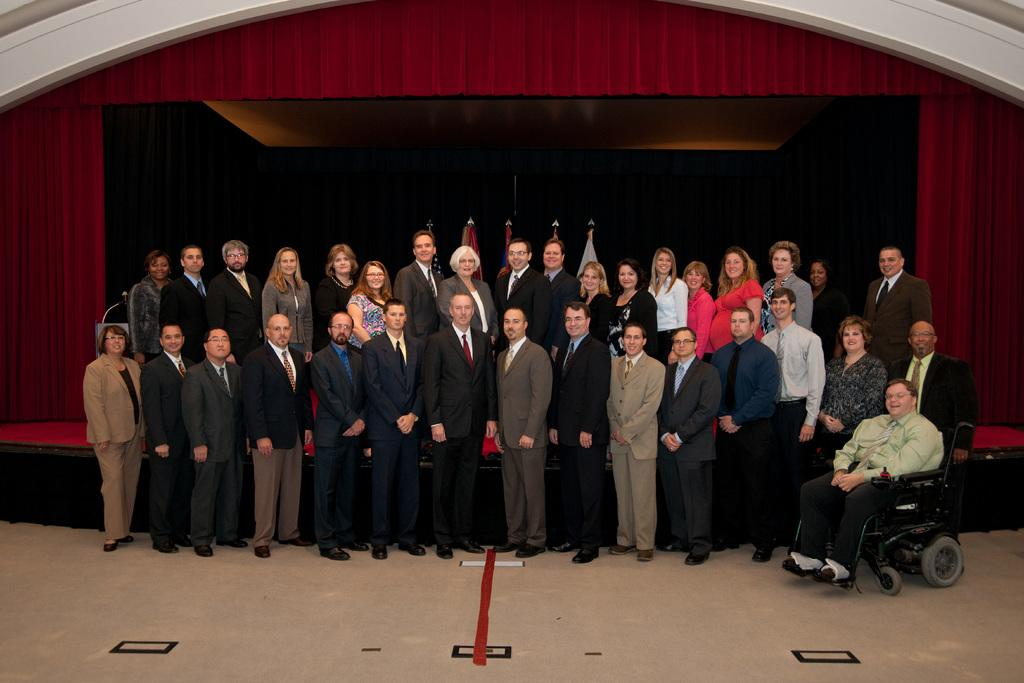How many people are in the image? There is a group of people in the image. What can be observed about the clothing of the people in the image? The people are wearing different color dresses. Can you describe the seating arrangement of one of the individuals in the image? One person is sitting on a wheelchair. What colors can be seen in the curtains in the background of the image? There are red and black color curtains in the background. What type of jam is being served to the people in the image? There is no jam present in the image. Is the birth of a new family member being celebrated in the image? There is no indication of a celebration or a new family member in the image. 